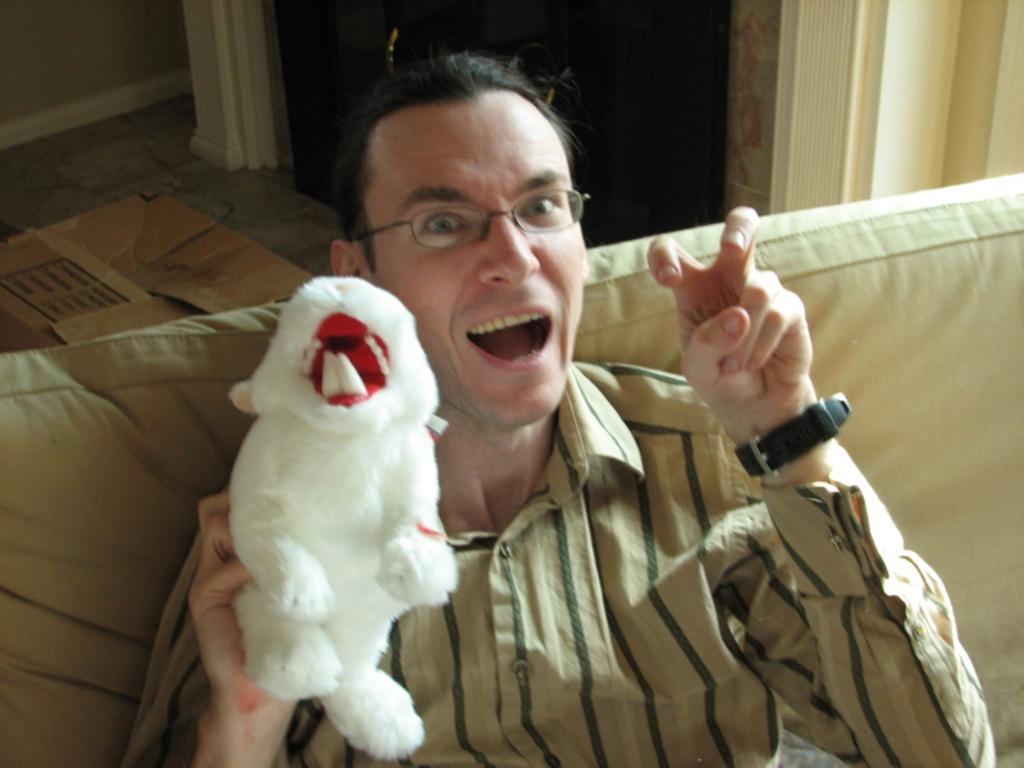What is the man in the image doing? The man is sitting on a couch in the image. What is the man holding in the image? The man is holding a toy in the image. What is the man's facial expression in the image? The man's mouth is open in the image. What is located at the top of the image? There is a carton box at the top of the image. What can be seen on the floor in the image? The floor is visible in the image. What is present on one of the walls in the image? There is a wall in the image. What type of furniture is visible in the image? There is a cupboard with handles in the image. What type of cave can be seen in the background of the image? There is no cave present in the image; it is an indoor setting with a man sitting on a couch. 